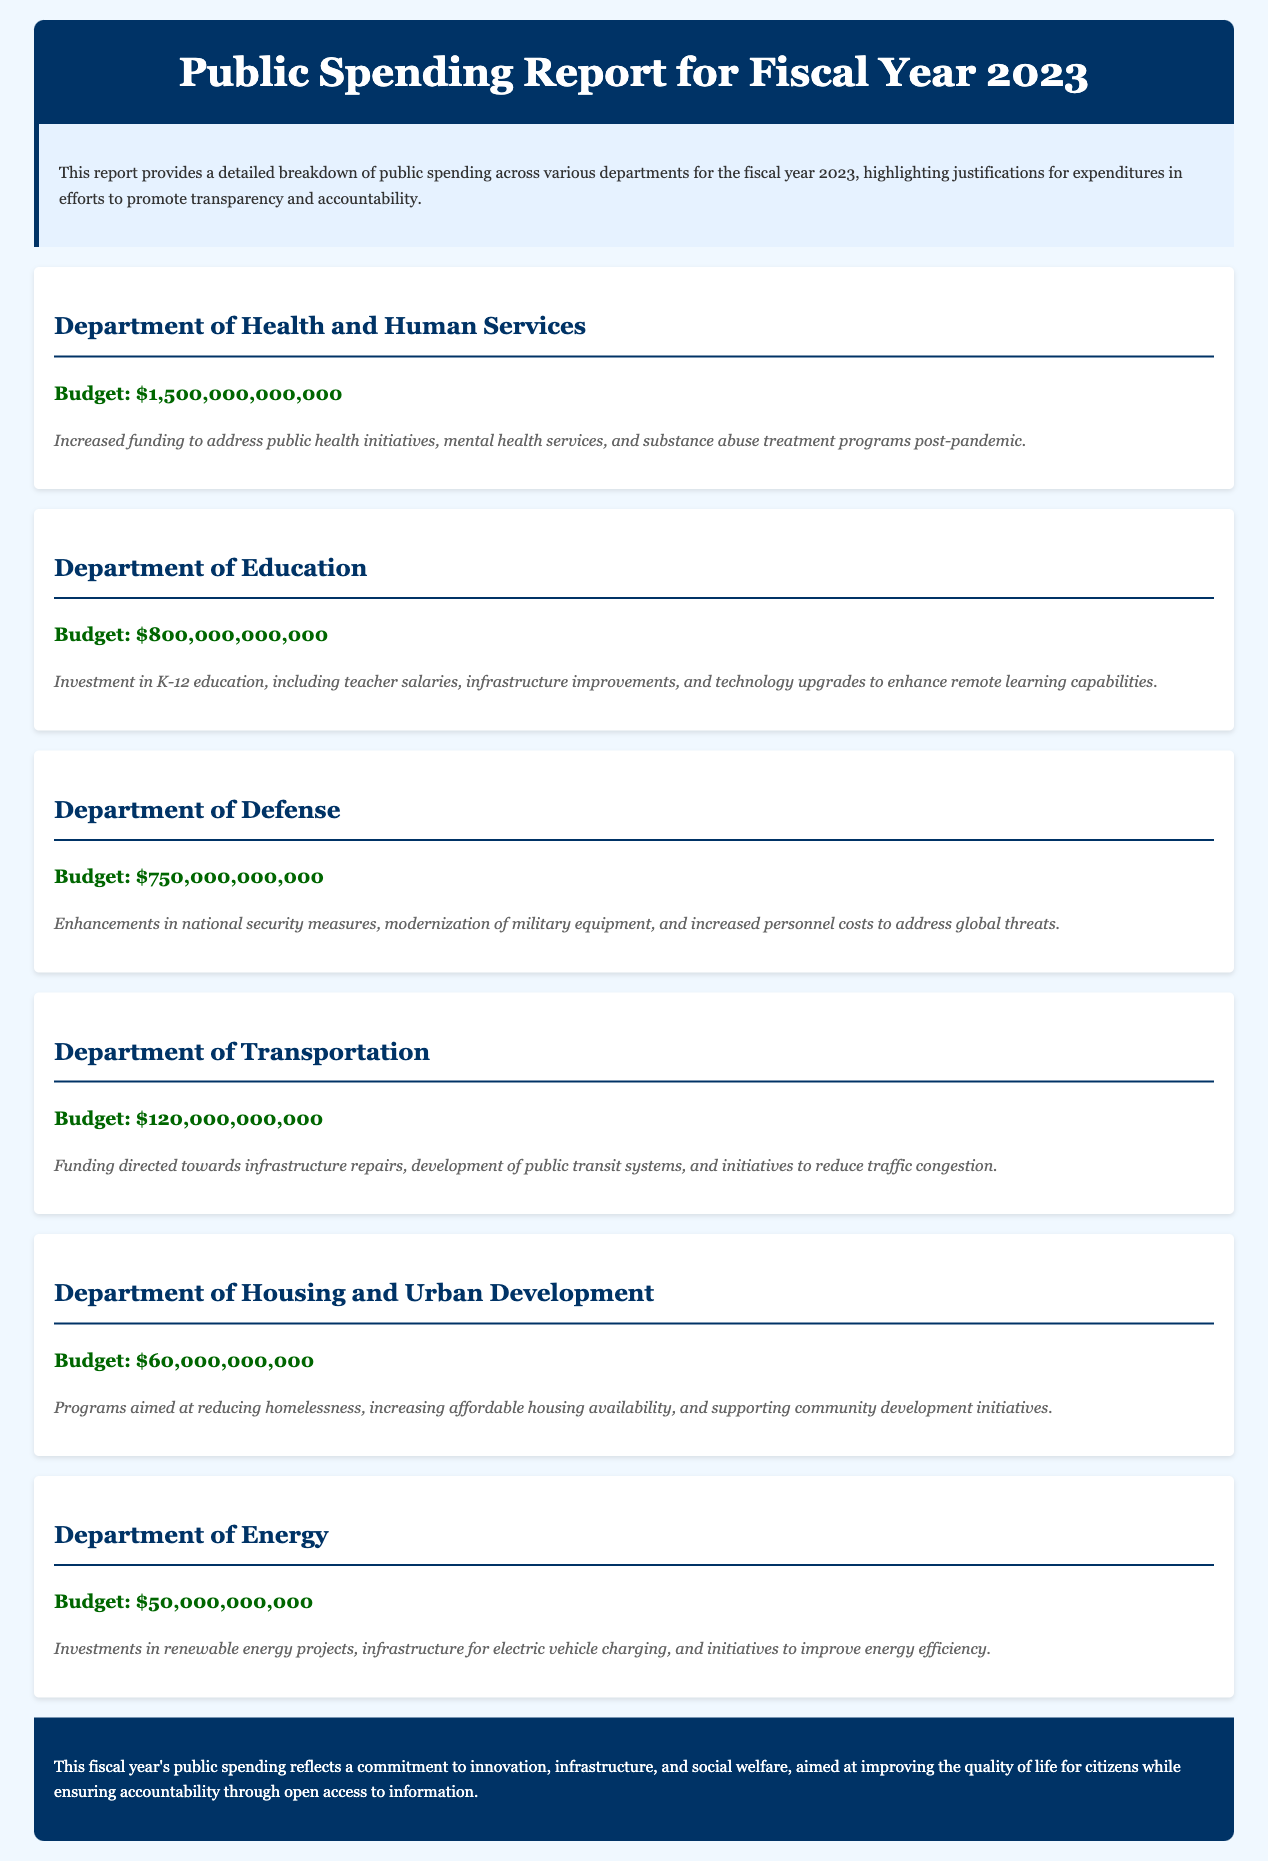What is the total budget for the Department of Health and Human Services? The budget for the Department of Health and Human Services is mentioned in the document as $1,500,000,000,000.
Answer: $1,500,000,000,000 What is the budget for the Department of Education? The budget is explicitly stated in the document as $800,000,000,000.
Answer: $800,000,000,000 What major initiative is addressed by the Department of Transportation's budget? The document highlights funding directed toward infrastructure repairs among other initiatives.
Answer: Infrastructure repairs What is the budget amount for the Department of Energy? The budget is provided in the document as $50,000,000,000.
Answer: $50,000,000,000 What is a key focus for the Department of Housing and Urban Development? The justification highlights programs aimed at reducing homelessness as a key focus.
Answer: Reducing homelessness How much is allocated for the Department of Defense? The document clearly specifies the budget for the Department of Defense as $750,000,000,000.
Answer: $750,000,000,000 Which department's funding is directed towards public health initiatives? The document specifies that the Department of Health and Human Services has funding for this purpose.
Answer: Department of Health and Human Services What is the total budget for the Department of Transportation? The budget for the Department of Transportation is stated as $120,000,000,000.
Answer: $120,000,000,000 What does the conclusion of the report emphasize? The conclusion highlights the commitment to innovation, infrastructure, and social welfare.
Answer: Innovation, infrastructure, and social welfare 